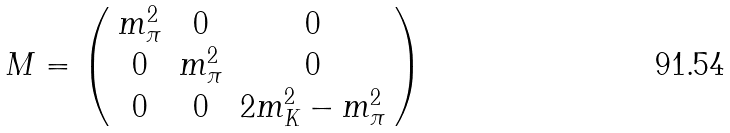Convert formula to latex. <formula><loc_0><loc_0><loc_500><loc_500>M = \left ( \begin{array} { c c c } m ^ { 2 } _ { \pi } & 0 & 0 \\ 0 & m ^ { 2 } _ { \pi } & 0 \\ 0 & 0 & 2 m ^ { 2 } _ { K } - m ^ { 2 } _ { \pi } \end{array} \right )</formula> 